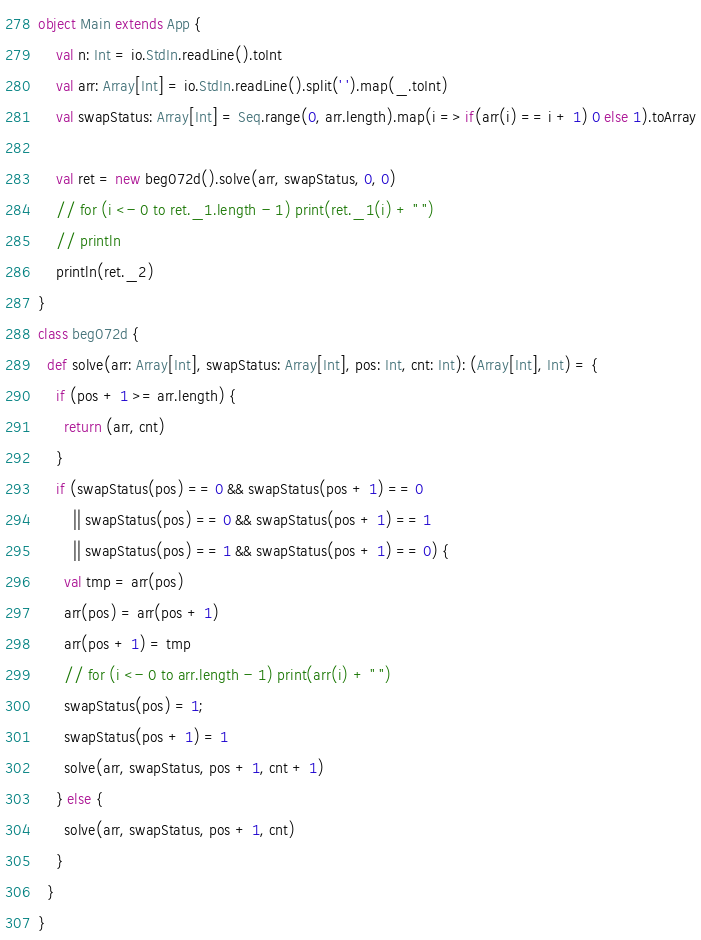Convert code to text. <code><loc_0><loc_0><loc_500><loc_500><_Scala_>object Main extends App {
    val n: Int = io.StdIn.readLine().toInt
    val arr: Array[Int] = io.StdIn.readLine().split(' ').map(_.toInt)
    val swapStatus: Array[Int] = Seq.range(0, arr.length).map(i => if(arr(i) == i + 1) 0 else 1).toArray

    val ret = new beg072d().solve(arr, swapStatus, 0, 0)
    // for (i <- 0 to ret._1.length - 1) print(ret._1(i) + " ")
    // println
    println(ret._2)
}
class beg072d {
  def solve(arr: Array[Int], swapStatus: Array[Int], pos: Int, cnt: Int): (Array[Int], Int) = {
    if (pos + 1 >= arr.length) {
      return (arr, cnt)
    }
    if (swapStatus(pos) == 0 && swapStatus(pos + 1) == 0
        || swapStatus(pos) == 0 && swapStatus(pos + 1) == 1
        || swapStatus(pos) == 1 && swapStatus(pos + 1) == 0) {
      val tmp = arr(pos)
      arr(pos) = arr(pos + 1)
      arr(pos + 1) = tmp
      // for (i <- 0 to arr.length - 1) print(arr(i) + " ")
      swapStatus(pos) = 1;
      swapStatus(pos + 1) = 1
      solve(arr, swapStatus, pos + 1, cnt + 1)
    } else {
      solve(arr, swapStatus, pos + 1, cnt)
    }
  }
}</code> 